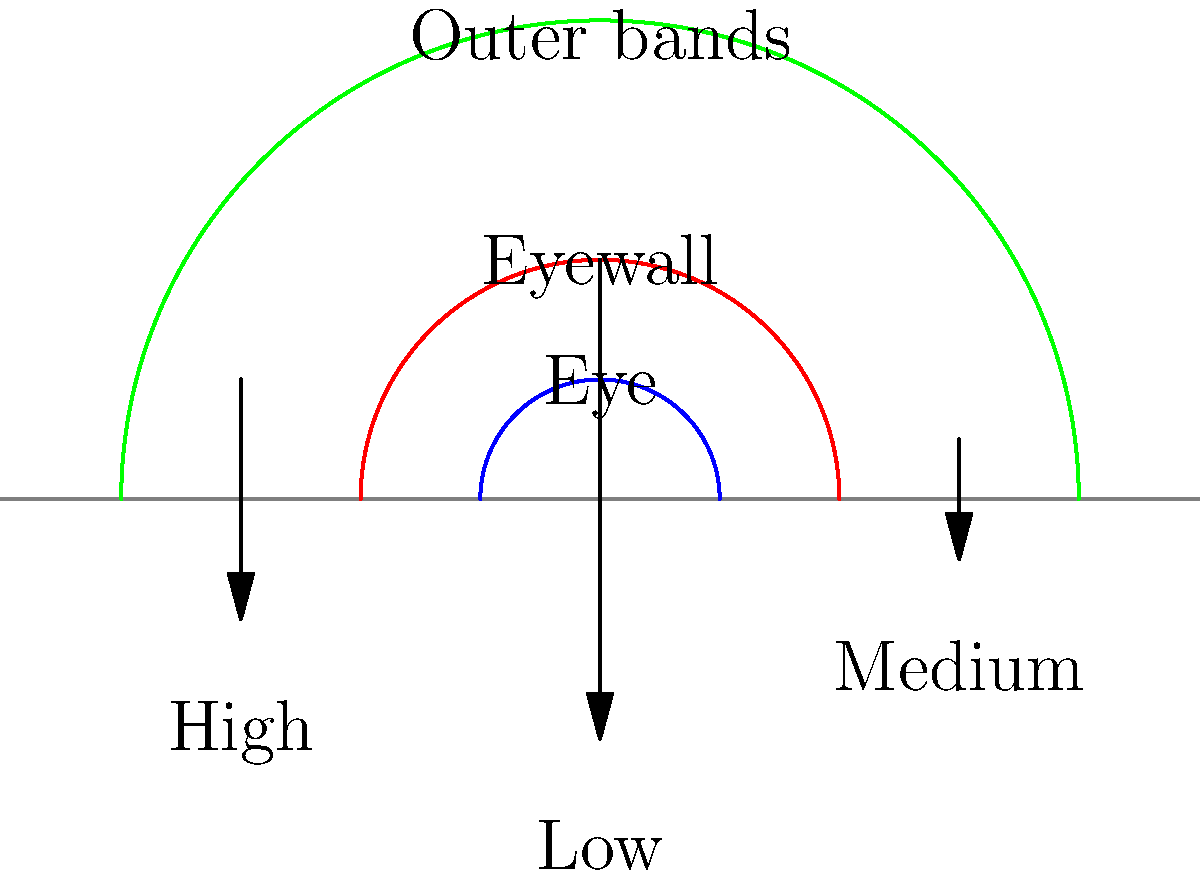In your latest historical fiction novel set in the Caribbean, you're describing a powerful hurricane approaching the islands. To add scientific accuracy to your narrative, you need to understand the pressure distribution within the storm. Based on the cross-sectional diagram of a hurricane, how does the air pressure typically vary from the outer bands to the eye of the storm? To understand the pressure distribution in a hurricane, let's analyze the diagram step-by-step:

1. Outer bands:
   - The outer regions of the hurricane show medium-length arrows pointing downward.
   - This indicates a moderate air pressure in the outer bands.

2. Moving inward:
   - As we move towards the center, we see longer arrows pointing downward near the eyewall.
   - Longer arrows suggest a more significant pressure difference, indicating lower air pressure.

3. Eye of the storm:
   - At the very center (the eye), we see shorter arrows pointing downward.
   - This represents a slight increase in pressure compared to the eyewall, but still lower than the outer bands.

The pressure distribution in a hurricane follows this pattern:
$$ P_{\text{outer bands}} > P_{\text{eye}} > P_{\text{eyewall}} $$

Where $P$ represents the air pressure in each region.

This pressure gradient is what drives the intense winds in a hurricane. Air moves from high-pressure areas to low-pressure areas, creating the circular motion characteristic of these storms.

In your novel, you could describe how characters feel the air pressure dropping as the storm approaches, with the lowest pressure occurring just before they enter the calm eye of the hurricane.
Answer: Pressure decreases from outer bands to eyewall, slightly increases in the eye, but remains lower than outer bands. 